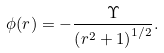<formula> <loc_0><loc_0><loc_500><loc_500>\phi ( r ) = - \frac { \Upsilon } { \left ( r ^ { 2 } + 1 \right ) ^ { 1 / 2 } } .</formula> 